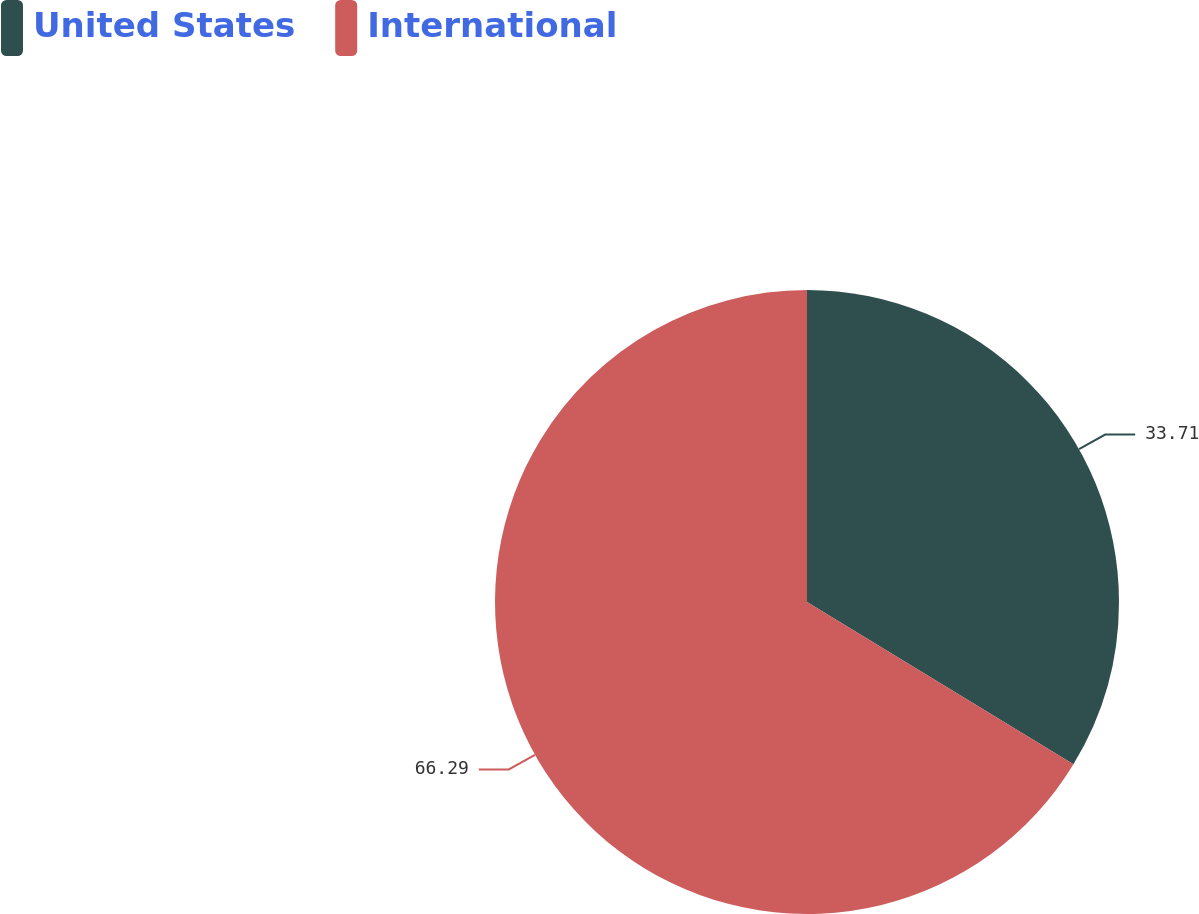<chart> <loc_0><loc_0><loc_500><loc_500><pie_chart><fcel>United States<fcel>International<nl><fcel>33.71%<fcel>66.29%<nl></chart> 